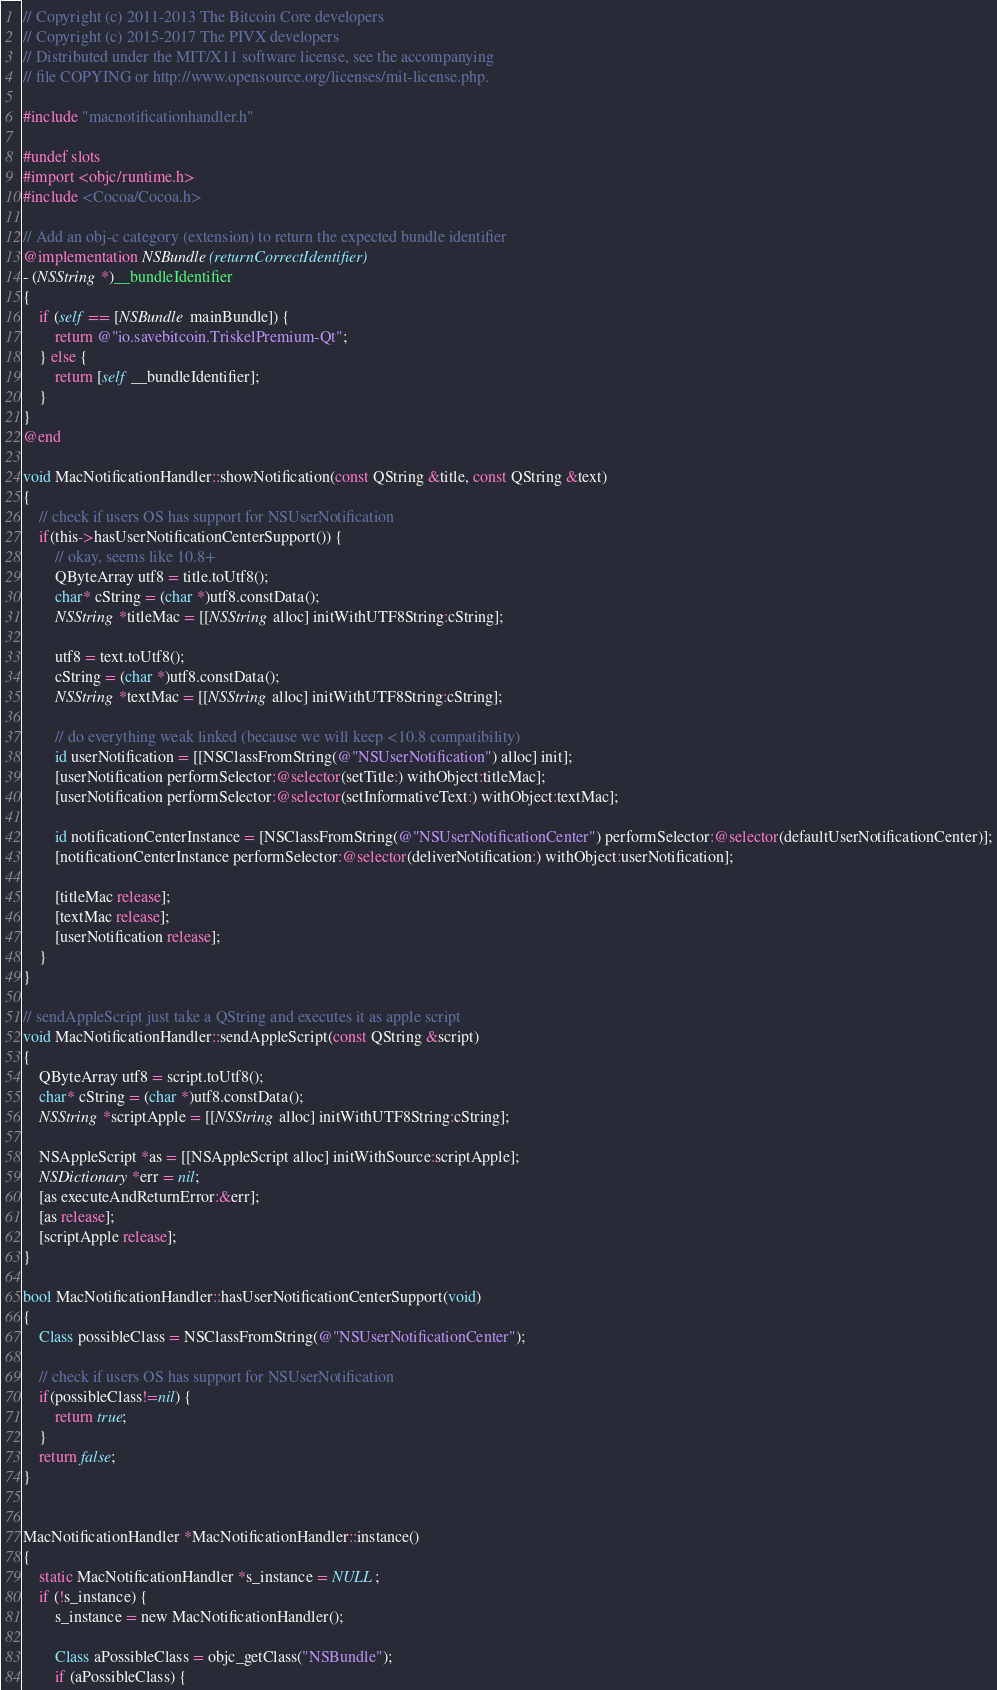<code> <loc_0><loc_0><loc_500><loc_500><_ObjectiveC_>// Copyright (c) 2011-2013 The Bitcoin Core developers
// Copyright (c) 2015-2017 The PIVX developers
// Distributed under the MIT/X11 software license, see the accompanying
// file COPYING or http://www.opensource.org/licenses/mit-license.php.

#include "macnotificationhandler.h"

#undef slots
#import <objc/runtime.h>
#include <Cocoa/Cocoa.h>

// Add an obj-c category (extension) to return the expected bundle identifier
@implementation NSBundle(returnCorrectIdentifier)
- (NSString *)__bundleIdentifier
{
    if (self == [NSBundle mainBundle]) {
        return @"io.savebitcoin.TriskelPremium-Qt";
    } else {
        return [self __bundleIdentifier];
    }
}
@end

void MacNotificationHandler::showNotification(const QString &title, const QString &text)
{
    // check if users OS has support for NSUserNotification
    if(this->hasUserNotificationCenterSupport()) {
        // okay, seems like 10.8+
        QByteArray utf8 = title.toUtf8();
        char* cString = (char *)utf8.constData();
        NSString *titleMac = [[NSString alloc] initWithUTF8String:cString];

        utf8 = text.toUtf8();
        cString = (char *)utf8.constData();
        NSString *textMac = [[NSString alloc] initWithUTF8String:cString];

        // do everything weak linked (because we will keep <10.8 compatibility)
        id userNotification = [[NSClassFromString(@"NSUserNotification") alloc] init];
        [userNotification performSelector:@selector(setTitle:) withObject:titleMac];
        [userNotification performSelector:@selector(setInformativeText:) withObject:textMac];

        id notificationCenterInstance = [NSClassFromString(@"NSUserNotificationCenter") performSelector:@selector(defaultUserNotificationCenter)];
        [notificationCenterInstance performSelector:@selector(deliverNotification:) withObject:userNotification];

        [titleMac release];
        [textMac release];
        [userNotification release];
    }
}

// sendAppleScript just take a QString and executes it as apple script
void MacNotificationHandler::sendAppleScript(const QString &script)
{
    QByteArray utf8 = script.toUtf8();
    char* cString = (char *)utf8.constData();
    NSString *scriptApple = [[NSString alloc] initWithUTF8String:cString];

    NSAppleScript *as = [[NSAppleScript alloc] initWithSource:scriptApple];
    NSDictionary *err = nil;
    [as executeAndReturnError:&err];
    [as release];
    [scriptApple release];
}

bool MacNotificationHandler::hasUserNotificationCenterSupport(void)
{
    Class possibleClass = NSClassFromString(@"NSUserNotificationCenter");

    // check if users OS has support for NSUserNotification
    if(possibleClass!=nil) {
        return true;
    }
    return false;
}


MacNotificationHandler *MacNotificationHandler::instance()
{
    static MacNotificationHandler *s_instance = NULL;
    if (!s_instance) {
        s_instance = new MacNotificationHandler();
        
        Class aPossibleClass = objc_getClass("NSBundle");
        if (aPossibleClass) {</code> 